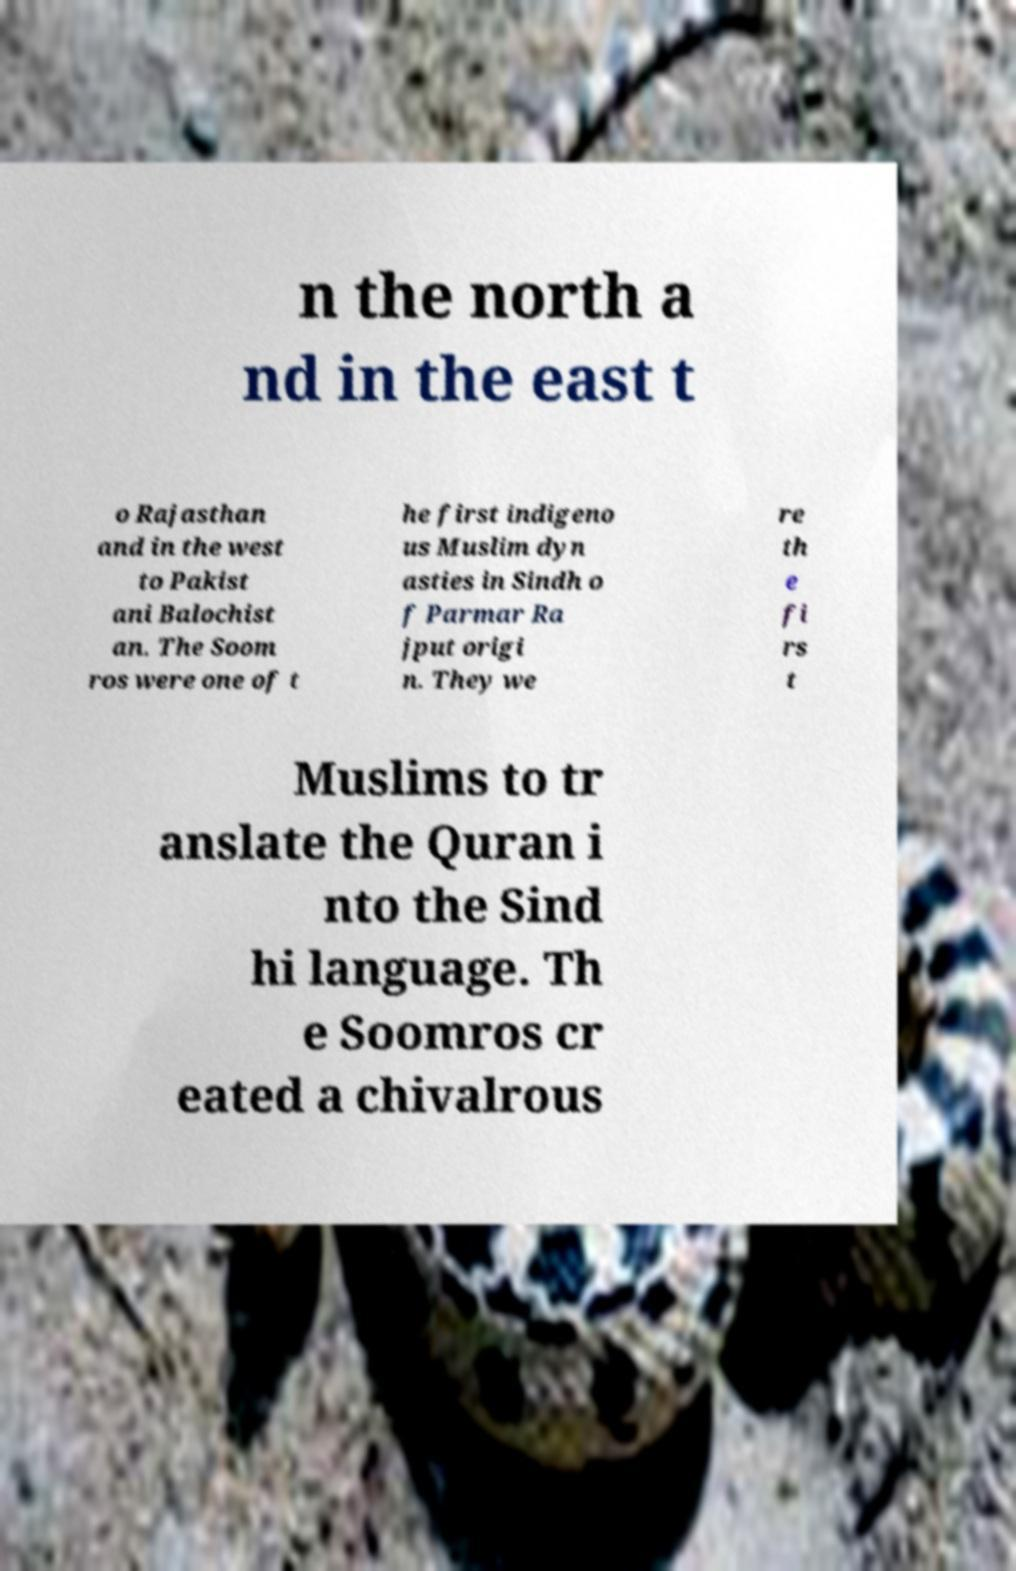Could you extract and type out the text from this image? n the north a nd in the east t o Rajasthan and in the west to Pakist ani Balochist an. The Soom ros were one of t he first indigeno us Muslim dyn asties in Sindh o f Parmar Ra jput origi n. They we re th e fi rs t Muslims to tr anslate the Quran i nto the Sind hi language. Th e Soomros cr eated a chivalrous 